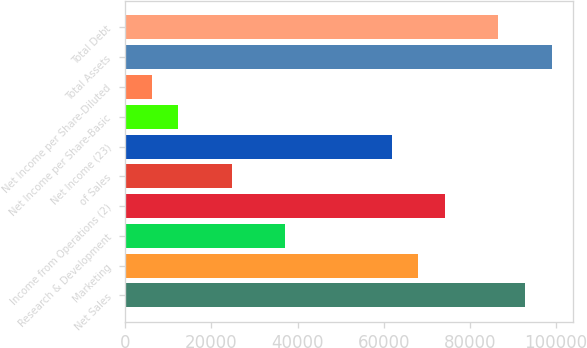Convert chart to OTSL. <chart><loc_0><loc_0><loc_500><loc_500><bar_chart><fcel>Net Sales<fcel>Marketing<fcel>Research & Development<fcel>Income from Operations (2)<fcel>of Sales<fcel>Net Income (23)<fcel>Net Income per Share-Basic<fcel>Net Income per Share-Diluted<fcel>Total Assets<fcel>Total Debt<nl><fcel>92801.9<fcel>68054.8<fcel>37120.9<fcel>74241.6<fcel>24747.3<fcel>61868<fcel>12373.8<fcel>6187.01<fcel>98988.7<fcel>86615.1<nl></chart> 